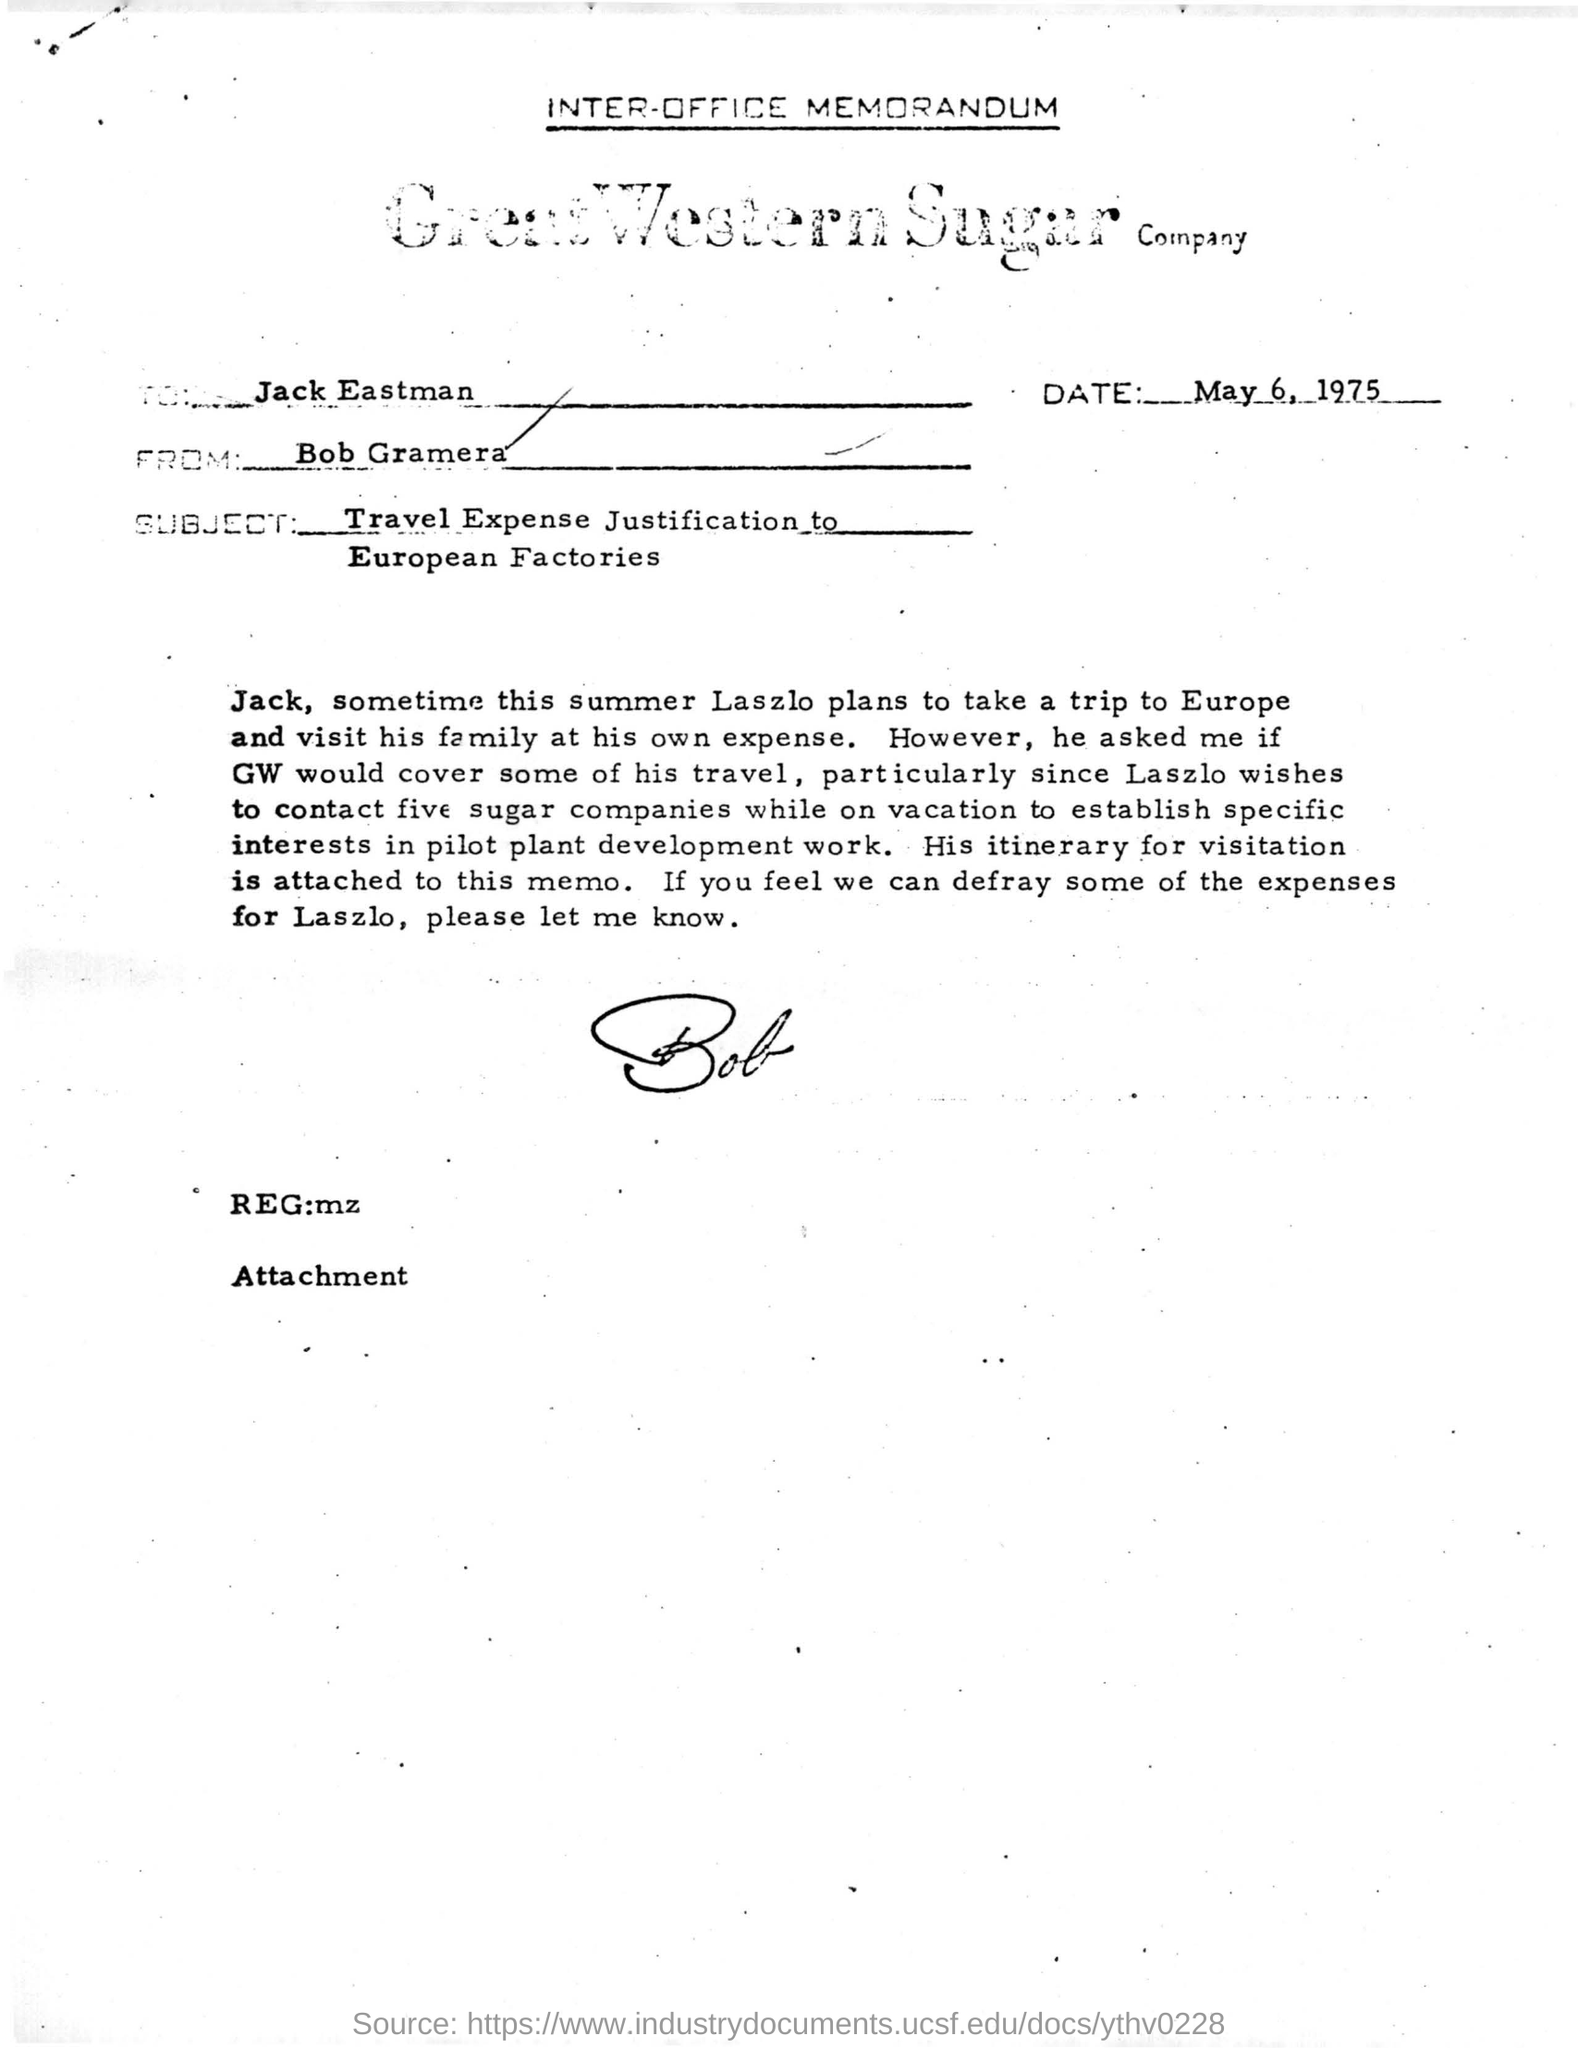Draw attention to some important aspects in this diagram. The subject of this letter is the justification of travel expenses to European factories. The sender of this letter is Bob Gramera. The letter is addressed to Jack Eastman. The name of the company is Great Western Sugar Company. This document was created on May 6, 1975. 